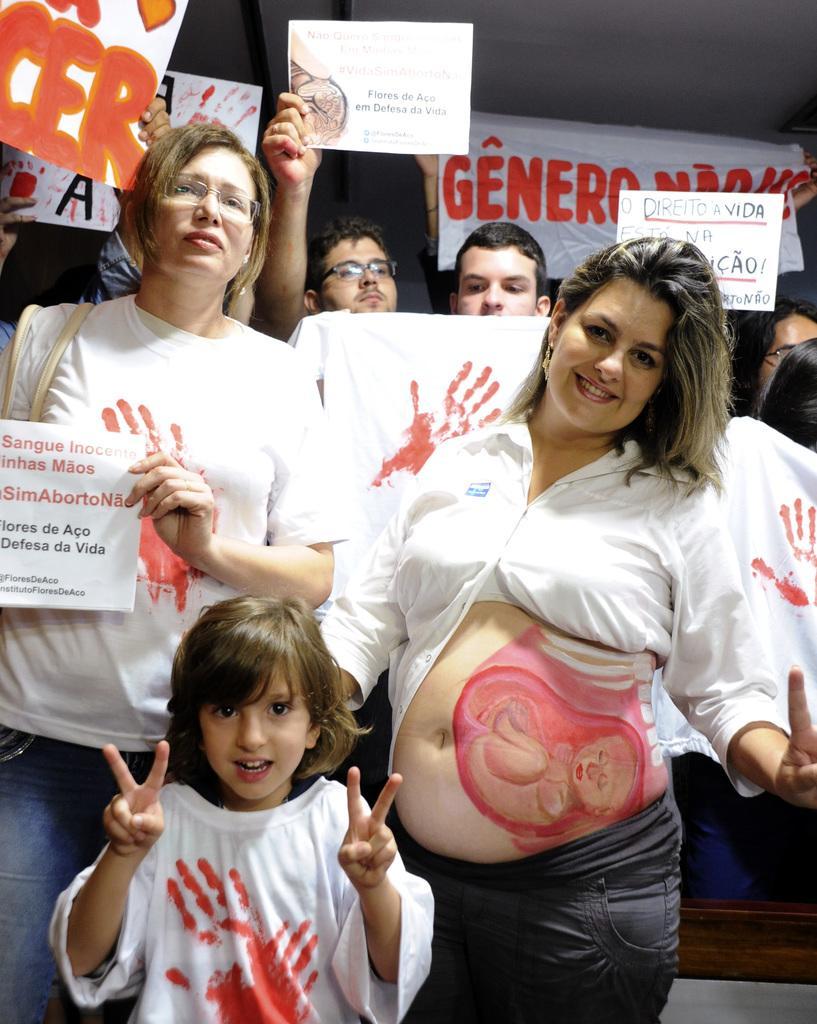How would you summarize this image in a sentence or two? This is the picture of some people, among them a lady has some painting on her stomach and behind there are some other people holding some boards. 